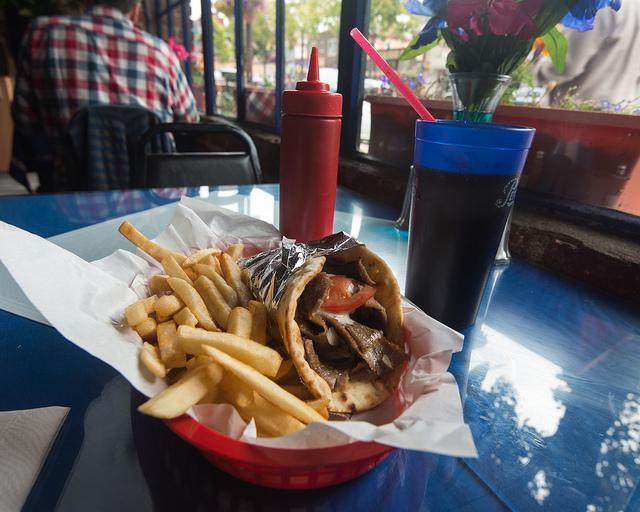What type of food is in the tinfoil?
Indicate the correct choice and explain in the format: 'Answer: answer
Rationale: rationale.'
Options: Pita, tortilla, laffa, pie. Answer: laffa.
Rationale: The pita like bread with meat inside  is common with this iraqi cuisine. 